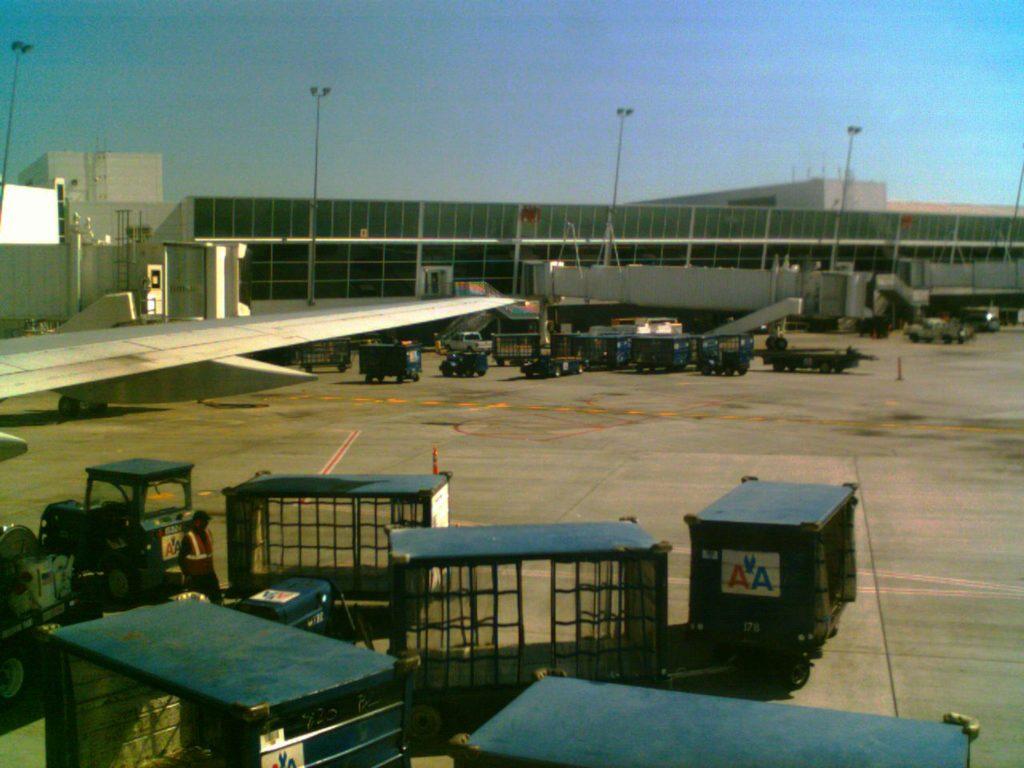What is the place?
Provide a succinct answer. Answering does not require reading text in the image. 